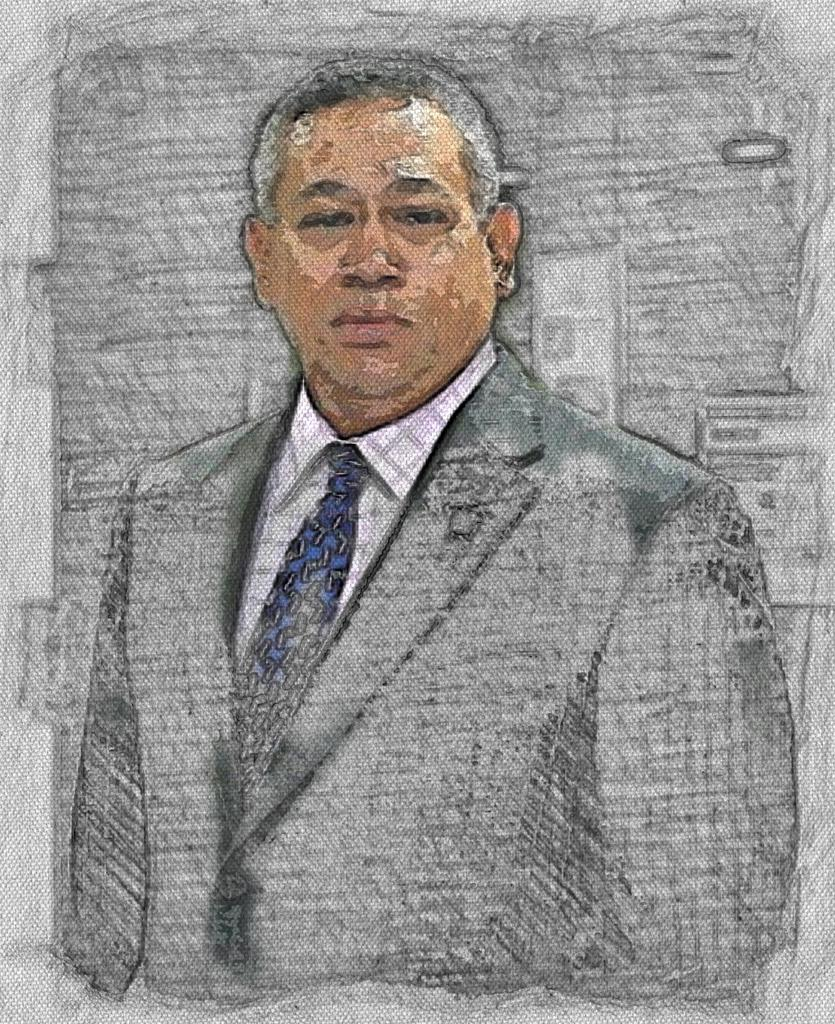What can be observed about the image? The image is edited. Can you describe the person in the image? There is a person in the image, and they are wearing a blazer. What type of secretary can be seen learning about planes in the image? There is no secretary or mention of planes in the image; it only features a person wearing a blazer. 